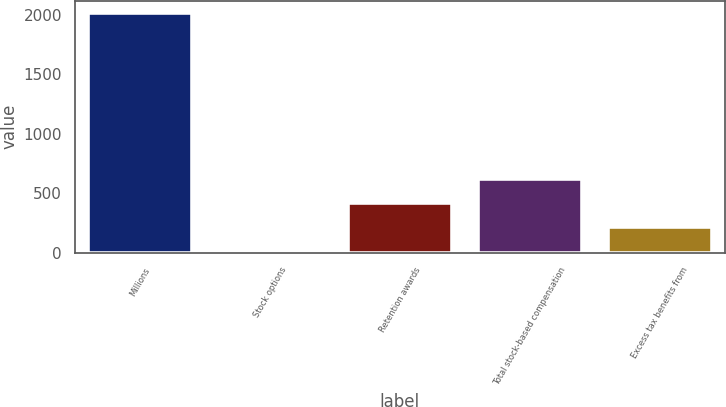<chart> <loc_0><loc_0><loc_500><loc_500><bar_chart><fcel>Millions<fcel>Stock options<fcel>Retention awards<fcel>Total stock-based compensation<fcel>Excess tax benefits from<nl><fcel>2015<fcel>17<fcel>416.6<fcel>616.4<fcel>216.8<nl></chart> 